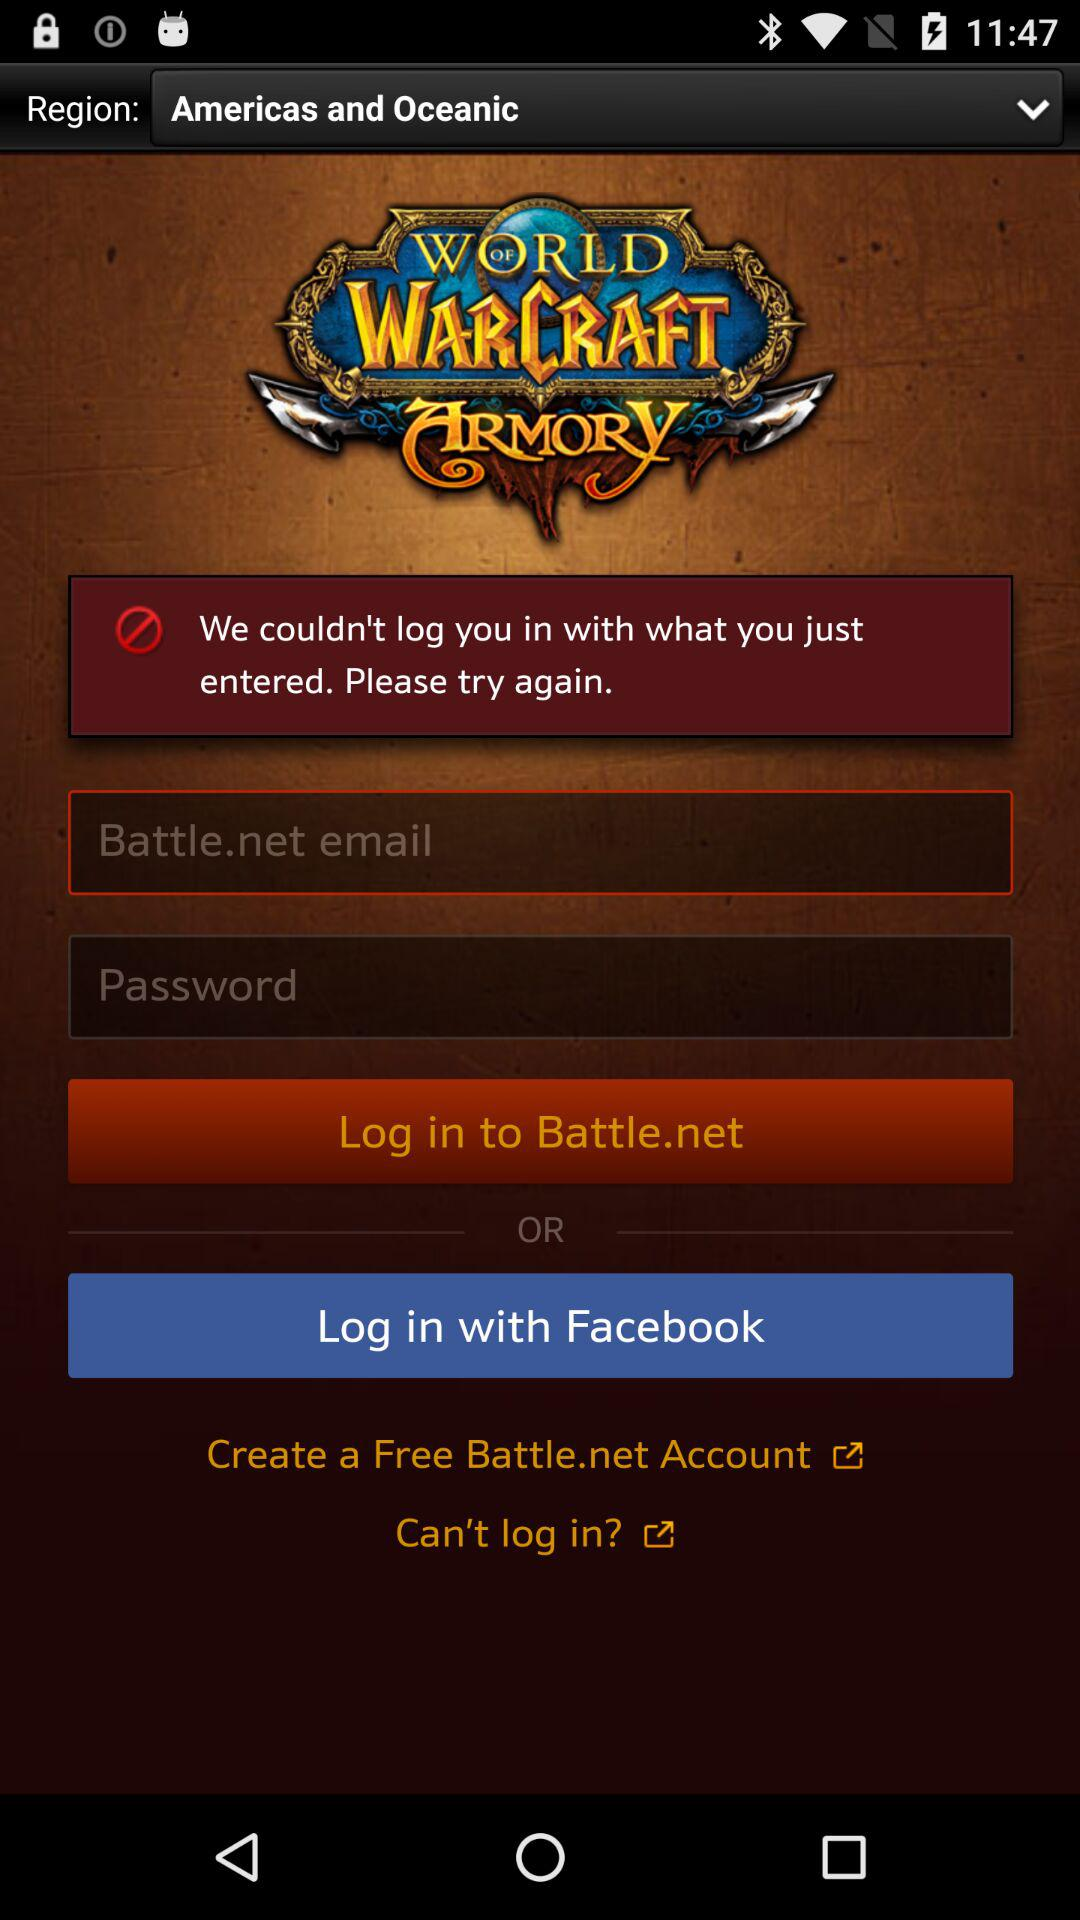Which application can we use to log in? You can use the applications "Battle.net" and "Facebook" to log in. 